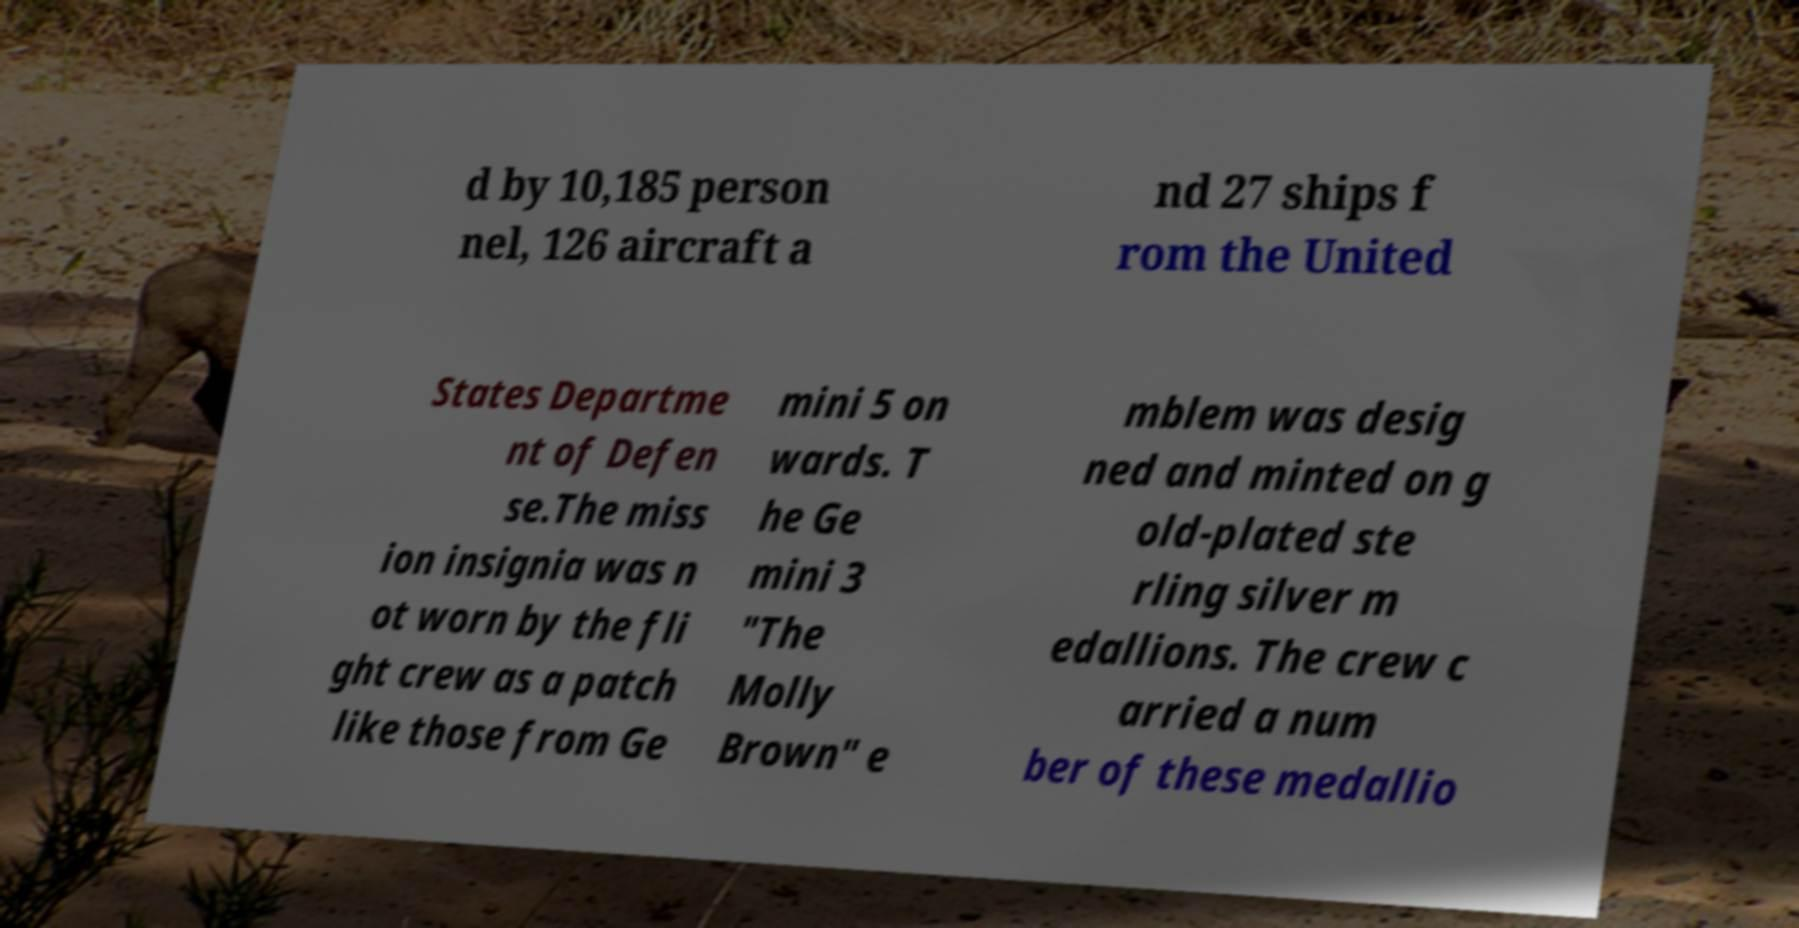There's text embedded in this image that I need extracted. Can you transcribe it verbatim? d by 10,185 person nel, 126 aircraft a nd 27 ships f rom the United States Departme nt of Defen se.The miss ion insignia was n ot worn by the fli ght crew as a patch like those from Ge mini 5 on wards. T he Ge mini 3 "The Molly Brown" e mblem was desig ned and minted on g old-plated ste rling silver m edallions. The crew c arried a num ber of these medallio 